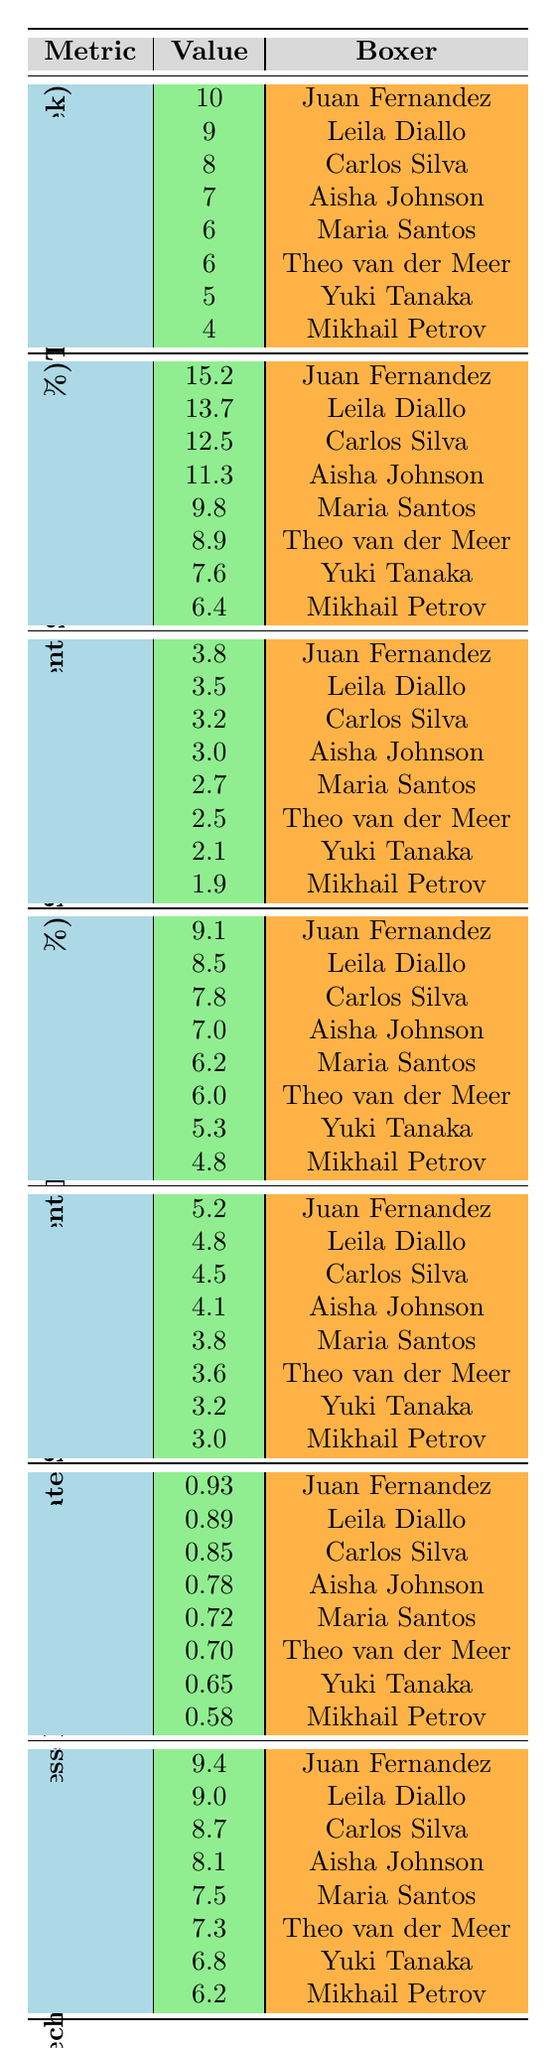What is the punch speed increase percentage for Juan Fernandez? The table shows that the punch speed increase percentage for Juan Fernandez is 15.2%.
Answer: 15.2% Which boxer has the highest injury prevention score improvement? According to the table, the boxer with the highest injury prevention score improvement is Juan Fernandez with a score of 5.2.
Answer: Juan Fernandez How many hours per week of flexibility training does Aisha Johnson do? The table indicates that Aisha Johnson does 7 hours of flexibility training per week.
Answer: 7 What is the average punching power increase percentage for all boxers? To find the average, first sum all values of punching power increase percentages: 7.8 + 6.2 + 9.1 + 7.0 + 6.2 + 6.0 + 5.3 + 4.8 = 52.4. Then divide by 8; the average is 52.4 / 8 = 6.55.
Answer: 6.55 Is there any boxer with a punching power increase percentage less than 6.0%? Yes, according to the table, Mikhail Petrov has a punching power increase percentage of 4.8%, which is less than 6.0%.
Answer: Yes What is the difference between the footwork agility score improvement of Juan Fernandez and Yuki Tanaka? The footwork agility score improvement for Juan Fernandez is 3.8, and for Yuki Tanaka, it is 2.1. The difference is 3.8 - 2.1, which equals 1.7.
Answer: 1.7 Which boxer demonstrates the best acrobatic move incorporation rate? Juan Fernandez has the highest acrobatic move incorporation rate of 0.93, as stated in the table.
Answer: Juan Fernandez What is the total flexibility training hours per week for all boxers combined? By summing the flexibility training hours per week: 8 + 6 + 10 + 5 + 7 + 4 + 9 + 6 = 55 hours total.
Answer: 55 Which boxer has the lowest capoeira technique effectiveness score? The lowest capoeira technique effectiveness score is 6.2, belonging to Mikhail Petrov, according to the table.
Answer: Mikhail Petrov Are most boxers achieving a punch speed increase of more than 10%? Yes, examining the table shows that four out of the eight boxers have a punch speed increase of more than 10%.
Answer: Yes Who has the second highest footwork agility score improvement and what is the score? The second highest score in footwork agility improvement is 3.5 by Leila Diallo, as indicated in the table.
Answer: Leila Diallo, 3.5 